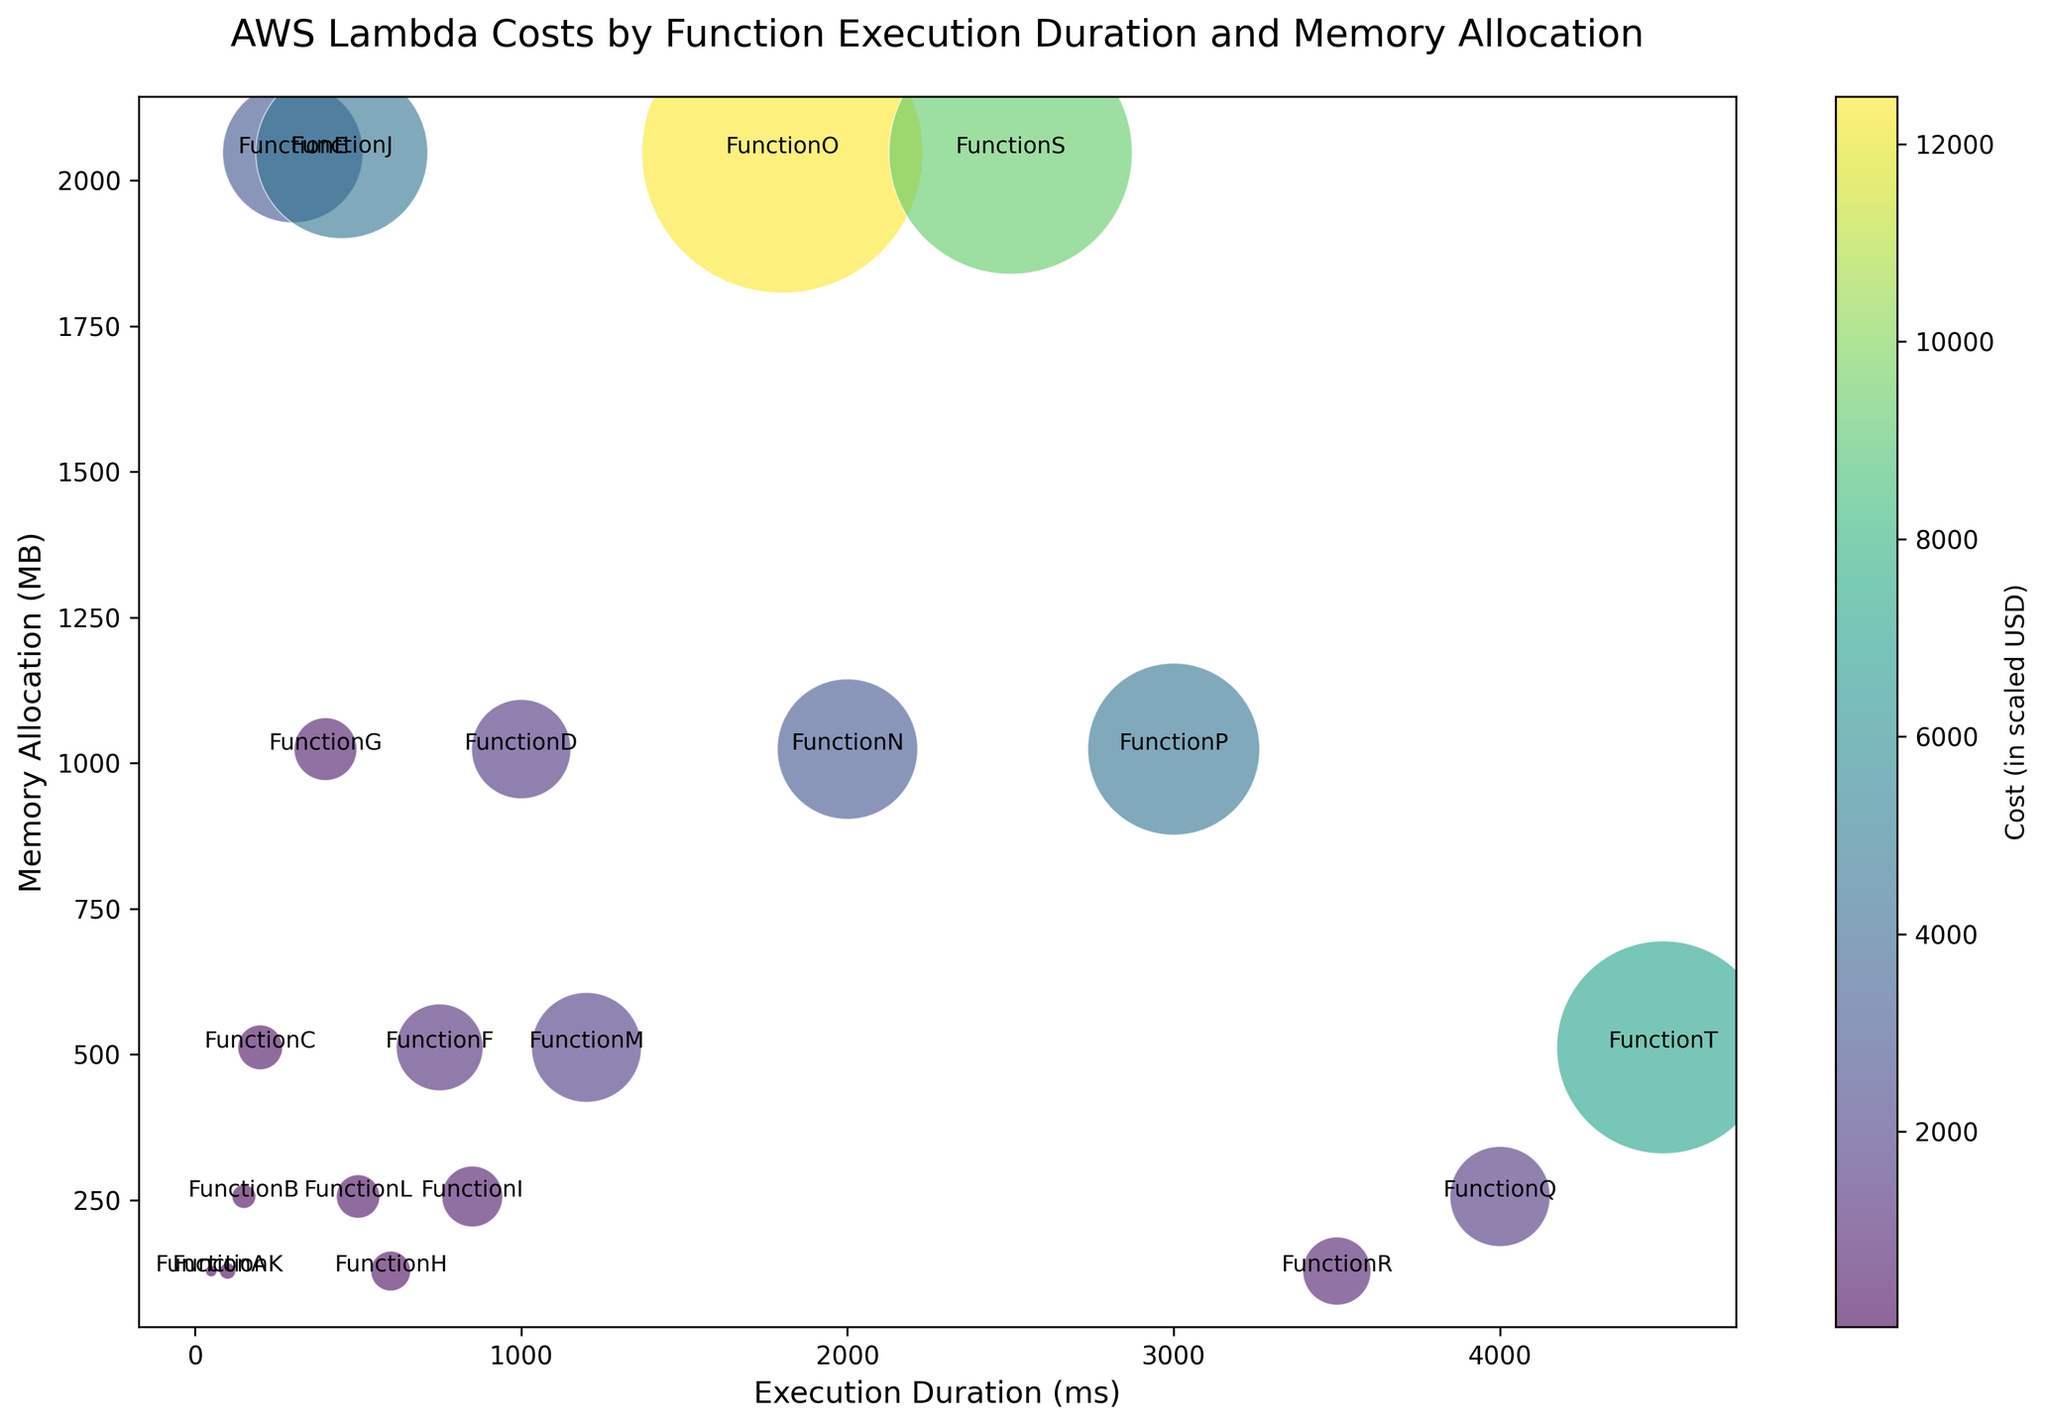What's the execution duration of the function with the largest bubble? The function with the largest bubble represents the highest cost. By inspecting the plot visually, the function with the largest bubble is FunctionO, which has an execution duration of 1800 ms
Answer: 1800 ms Which function has the highest memory allocation? To determine which function has the highest memory allocation, we look for the bubble positioned highest vertically. By observing the y-axis, FunctionE, FunctionJ, FunctionO, and FunctionS have the highest memory allocation of 2048 MB.
Answer: FunctionE, FunctionJ, FunctionO, FunctionS Compare the cost of FunctionK and FunctionD, which one costs more? The cost of a function is represented by the size of the bubble. By comparing the sizes of the bubbles for FunctionK and FunctionD, it is apparent that FunctionD's bubble is larger than FunctionK's. Therefore, FunctionD costs more.
Answer: FunctionD What is the average memory allocation for functions with a duration between 200ms and 1000ms? First, identify the functions between 200ms and 1000ms: FunctionC, FunctionE, FunctionF, FunctionG, FunctionH, FunctionI. Next, sum their memory allocations: 512 + 2048 + 512 + 1024 + 128 + 256 = 4480. Divide this sum by the number of functions (6).
Answer: 4480 / 6 = 746.67 MB Which function has the longest execution duration? The function with the longest execution duration will be the bubble farthest to the right on the x-axis. Observing the plot, FunctionT has the longest execution duration at 4500 ms.
Answer: FunctionT What is the total cost of functions with execution durations above 3000ms? Functions above 3000ms are FunctionQ, FunctionR, FunctionS, FunctionT. Summing their costs: 0.00001587 + 0.00000735 + 0.00009360 + 0.00007170 = 0.00018852.
Answer: 0.00018852 USD Which function has the smallest bubble? The smallest bubble represents the lowest cost. By visually inspecting the plot, the smallest bubble corresponds to FunctionA with a cost of 0.00000021 USD.
Answer: FunctionA 